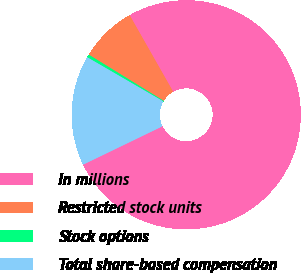Convert chart to OTSL. <chart><loc_0><loc_0><loc_500><loc_500><pie_chart><fcel>In millions<fcel>Restricted stock units<fcel>Stock options<fcel>Total share-based compensation<nl><fcel>76.06%<fcel>7.98%<fcel>0.42%<fcel>15.54%<nl></chart> 